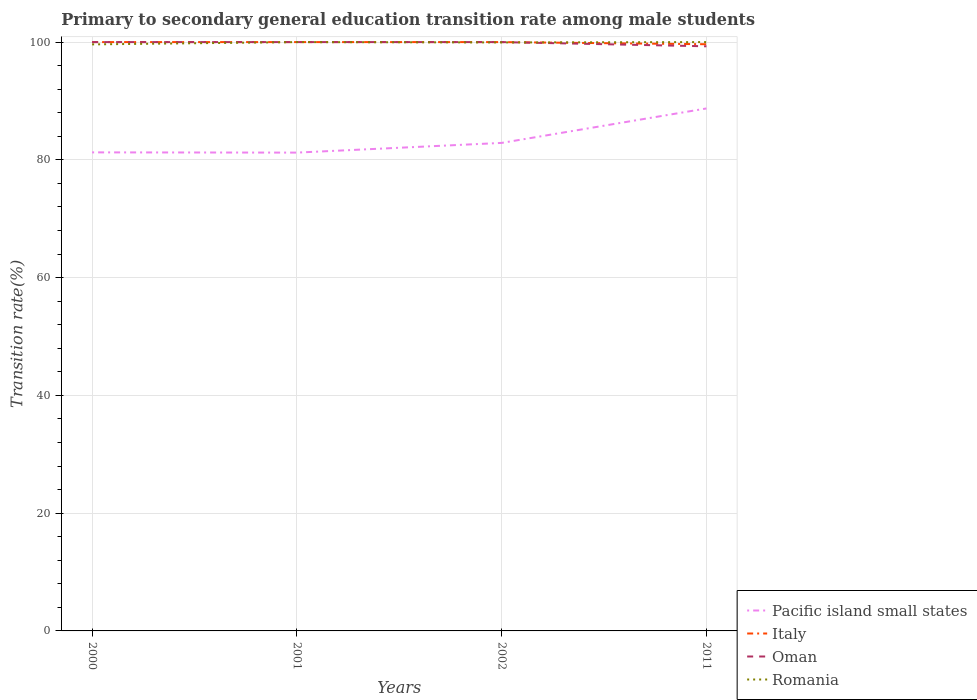Does the line corresponding to Romania intersect with the line corresponding to Italy?
Ensure brevity in your answer.  Yes. Across all years, what is the maximum transition rate in Italy?
Ensure brevity in your answer.  99.64. In which year was the transition rate in Pacific island small states maximum?
Keep it short and to the point. 2001. What is the total transition rate in Pacific island small states in the graph?
Your answer should be compact. -1.61. What is the difference between the highest and the second highest transition rate in Italy?
Offer a very short reply. 0.36. What is the difference between the highest and the lowest transition rate in Romania?
Provide a short and direct response. 3. Is the transition rate in Oman strictly greater than the transition rate in Pacific island small states over the years?
Your answer should be compact. No. How many lines are there?
Your response must be concise. 4. What is the difference between two consecutive major ticks on the Y-axis?
Offer a terse response. 20. Are the values on the major ticks of Y-axis written in scientific E-notation?
Your response must be concise. No. How many legend labels are there?
Ensure brevity in your answer.  4. How are the legend labels stacked?
Provide a succinct answer. Vertical. What is the title of the graph?
Your answer should be very brief. Primary to secondary general education transition rate among male students. Does "Colombia" appear as one of the legend labels in the graph?
Your answer should be compact. No. What is the label or title of the X-axis?
Give a very brief answer. Years. What is the label or title of the Y-axis?
Give a very brief answer. Transition rate(%). What is the Transition rate(%) in Pacific island small states in 2000?
Give a very brief answer. 81.27. What is the Transition rate(%) in Italy in 2000?
Keep it short and to the point. 100. What is the Transition rate(%) in Romania in 2000?
Your answer should be compact. 99.61. What is the Transition rate(%) of Pacific island small states in 2001?
Keep it short and to the point. 81.23. What is the Transition rate(%) of Italy in 2001?
Provide a short and direct response. 100. What is the Transition rate(%) in Oman in 2001?
Ensure brevity in your answer.  100. What is the Transition rate(%) of Romania in 2001?
Provide a short and direct response. 100. What is the Transition rate(%) in Pacific island small states in 2002?
Keep it short and to the point. 82.88. What is the Transition rate(%) of Romania in 2002?
Ensure brevity in your answer.  99.94. What is the Transition rate(%) in Pacific island small states in 2011?
Ensure brevity in your answer.  88.73. What is the Transition rate(%) of Italy in 2011?
Your answer should be very brief. 99.64. What is the Transition rate(%) of Oman in 2011?
Keep it short and to the point. 99.29. What is the Transition rate(%) of Romania in 2011?
Give a very brief answer. 100. Across all years, what is the maximum Transition rate(%) of Pacific island small states?
Your answer should be very brief. 88.73. Across all years, what is the maximum Transition rate(%) in Italy?
Ensure brevity in your answer.  100. Across all years, what is the maximum Transition rate(%) in Romania?
Your answer should be compact. 100. Across all years, what is the minimum Transition rate(%) in Pacific island small states?
Keep it short and to the point. 81.23. Across all years, what is the minimum Transition rate(%) in Italy?
Your response must be concise. 99.64. Across all years, what is the minimum Transition rate(%) of Oman?
Your answer should be very brief. 99.29. Across all years, what is the minimum Transition rate(%) of Romania?
Make the answer very short. 99.61. What is the total Transition rate(%) in Pacific island small states in the graph?
Keep it short and to the point. 334.12. What is the total Transition rate(%) in Italy in the graph?
Offer a very short reply. 399.64. What is the total Transition rate(%) in Oman in the graph?
Ensure brevity in your answer.  399.29. What is the total Transition rate(%) of Romania in the graph?
Give a very brief answer. 399.55. What is the difference between the Transition rate(%) in Pacific island small states in 2000 and that in 2001?
Ensure brevity in your answer.  0.04. What is the difference between the Transition rate(%) in Italy in 2000 and that in 2001?
Give a very brief answer. 0. What is the difference between the Transition rate(%) of Romania in 2000 and that in 2001?
Your response must be concise. -0.39. What is the difference between the Transition rate(%) in Pacific island small states in 2000 and that in 2002?
Ensure brevity in your answer.  -1.61. What is the difference between the Transition rate(%) of Romania in 2000 and that in 2002?
Provide a short and direct response. -0.33. What is the difference between the Transition rate(%) in Pacific island small states in 2000 and that in 2011?
Keep it short and to the point. -7.46. What is the difference between the Transition rate(%) of Italy in 2000 and that in 2011?
Provide a succinct answer. 0.36. What is the difference between the Transition rate(%) in Oman in 2000 and that in 2011?
Offer a terse response. 0.71. What is the difference between the Transition rate(%) of Romania in 2000 and that in 2011?
Offer a very short reply. -0.39. What is the difference between the Transition rate(%) in Pacific island small states in 2001 and that in 2002?
Keep it short and to the point. -1.65. What is the difference between the Transition rate(%) of Romania in 2001 and that in 2002?
Provide a short and direct response. 0.06. What is the difference between the Transition rate(%) in Pacific island small states in 2001 and that in 2011?
Your answer should be very brief. -7.5. What is the difference between the Transition rate(%) of Italy in 2001 and that in 2011?
Provide a succinct answer. 0.36. What is the difference between the Transition rate(%) of Oman in 2001 and that in 2011?
Make the answer very short. 0.71. What is the difference between the Transition rate(%) in Pacific island small states in 2002 and that in 2011?
Make the answer very short. -5.85. What is the difference between the Transition rate(%) in Italy in 2002 and that in 2011?
Offer a very short reply. 0.36. What is the difference between the Transition rate(%) of Oman in 2002 and that in 2011?
Provide a short and direct response. 0.71. What is the difference between the Transition rate(%) in Romania in 2002 and that in 2011?
Offer a very short reply. -0.06. What is the difference between the Transition rate(%) in Pacific island small states in 2000 and the Transition rate(%) in Italy in 2001?
Your answer should be compact. -18.73. What is the difference between the Transition rate(%) of Pacific island small states in 2000 and the Transition rate(%) of Oman in 2001?
Your answer should be compact. -18.73. What is the difference between the Transition rate(%) in Pacific island small states in 2000 and the Transition rate(%) in Romania in 2001?
Your response must be concise. -18.73. What is the difference between the Transition rate(%) of Pacific island small states in 2000 and the Transition rate(%) of Italy in 2002?
Keep it short and to the point. -18.73. What is the difference between the Transition rate(%) of Pacific island small states in 2000 and the Transition rate(%) of Oman in 2002?
Provide a short and direct response. -18.73. What is the difference between the Transition rate(%) in Pacific island small states in 2000 and the Transition rate(%) in Romania in 2002?
Your answer should be compact. -18.67. What is the difference between the Transition rate(%) in Italy in 2000 and the Transition rate(%) in Romania in 2002?
Provide a short and direct response. 0.06. What is the difference between the Transition rate(%) of Oman in 2000 and the Transition rate(%) of Romania in 2002?
Provide a succinct answer. 0.06. What is the difference between the Transition rate(%) in Pacific island small states in 2000 and the Transition rate(%) in Italy in 2011?
Ensure brevity in your answer.  -18.36. What is the difference between the Transition rate(%) in Pacific island small states in 2000 and the Transition rate(%) in Oman in 2011?
Offer a terse response. -18.01. What is the difference between the Transition rate(%) of Pacific island small states in 2000 and the Transition rate(%) of Romania in 2011?
Provide a short and direct response. -18.73. What is the difference between the Transition rate(%) in Italy in 2000 and the Transition rate(%) in Oman in 2011?
Provide a succinct answer. 0.71. What is the difference between the Transition rate(%) of Pacific island small states in 2001 and the Transition rate(%) of Italy in 2002?
Keep it short and to the point. -18.77. What is the difference between the Transition rate(%) in Pacific island small states in 2001 and the Transition rate(%) in Oman in 2002?
Ensure brevity in your answer.  -18.77. What is the difference between the Transition rate(%) in Pacific island small states in 2001 and the Transition rate(%) in Romania in 2002?
Keep it short and to the point. -18.71. What is the difference between the Transition rate(%) of Italy in 2001 and the Transition rate(%) of Oman in 2002?
Make the answer very short. 0. What is the difference between the Transition rate(%) in Italy in 2001 and the Transition rate(%) in Romania in 2002?
Provide a succinct answer. 0.06. What is the difference between the Transition rate(%) in Oman in 2001 and the Transition rate(%) in Romania in 2002?
Make the answer very short. 0.06. What is the difference between the Transition rate(%) in Pacific island small states in 2001 and the Transition rate(%) in Italy in 2011?
Your answer should be compact. -18.4. What is the difference between the Transition rate(%) of Pacific island small states in 2001 and the Transition rate(%) of Oman in 2011?
Make the answer very short. -18.05. What is the difference between the Transition rate(%) in Pacific island small states in 2001 and the Transition rate(%) in Romania in 2011?
Give a very brief answer. -18.77. What is the difference between the Transition rate(%) of Italy in 2001 and the Transition rate(%) of Oman in 2011?
Offer a terse response. 0.71. What is the difference between the Transition rate(%) of Oman in 2001 and the Transition rate(%) of Romania in 2011?
Your answer should be compact. 0. What is the difference between the Transition rate(%) in Pacific island small states in 2002 and the Transition rate(%) in Italy in 2011?
Make the answer very short. -16.76. What is the difference between the Transition rate(%) in Pacific island small states in 2002 and the Transition rate(%) in Oman in 2011?
Provide a succinct answer. -16.41. What is the difference between the Transition rate(%) of Pacific island small states in 2002 and the Transition rate(%) of Romania in 2011?
Make the answer very short. -17.12. What is the difference between the Transition rate(%) of Italy in 2002 and the Transition rate(%) of Oman in 2011?
Your answer should be compact. 0.71. What is the average Transition rate(%) in Pacific island small states per year?
Give a very brief answer. 83.53. What is the average Transition rate(%) of Italy per year?
Provide a succinct answer. 99.91. What is the average Transition rate(%) of Oman per year?
Provide a succinct answer. 99.82. What is the average Transition rate(%) of Romania per year?
Offer a very short reply. 99.89. In the year 2000, what is the difference between the Transition rate(%) of Pacific island small states and Transition rate(%) of Italy?
Give a very brief answer. -18.73. In the year 2000, what is the difference between the Transition rate(%) in Pacific island small states and Transition rate(%) in Oman?
Your answer should be very brief. -18.73. In the year 2000, what is the difference between the Transition rate(%) in Pacific island small states and Transition rate(%) in Romania?
Offer a very short reply. -18.34. In the year 2000, what is the difference between the Transition rate(%) in Italy and Transition rate(%) in Romania?
Keep it short and to the point. 0.39. In the year 2000, what is the difference between the Transition rate(%) in Oman and Transition rate(%) in Romania?
Offer a very short reply. 0.39. In the year 2001, what is the difference between the Transition rate(%) of Pacific island small states and Transition rate(%) of Italy?
Your answer should be very brief. -18.77. In the year 2001, what is the difference between the Transition rate(%) in Pacific island small states and Transition rate(%) in Oman?
Your answer should be very brief. -18.77. In the year 2001, what is the difference between the Transition rate(%) of Pacific island small states and Transition rate(%) of Romania?
Give a very brief answer. -18.77. In the year 2001, what is the difference between the Transition rate(%) of Italy and Transition rate(%) of Romania?
Keep it short and to the point. 0. In the year 2002, what is the difference between the Transition rate(%) in Pacific island small states and Transition rate(%) in Italy?
Provide a short and direct response. -17.12. In the year 2002, what is the difference between the Transition rate(%) of Pacific island small states and Transition rate(%) of Oman?
Give a very brief answer. -17.12. In the year 2002, what is the difference between the Transition rate(%) of Pacific island small states and Transition rate(%) of Romania?
Your answer should be very brief. -17.06. In the year 2002, what is the difference between the Transition rate(%) of Italy and Transition rate(%) of Oman?
Ensure brevity in your answer.  0. In the year 2002, what is the difference between the Transition rate(%) in Italy and Transition rate(%) in Romania?
Your answer should be compact. 0.06. In the year 2002, what is the difference between the Transition rate(%) of Oman and Transition rate(%) of Romania?
Your response must be concise. 0.06. In the year 2011, what is the difference between the Transition rate(%) in Pacific island small states and Transition rate(%) in Italy?
Your answer should be very brief. -10.91. In the year 2011, what is the difference between the Transition rate(%) in Pacific island small states and Transition rate(%) in Oman?
Your answer should be very brief. -10.56. In the year 2011, what is the difference between the Transition rate(%) in Pacific island small states and Transition rate(%) in Romania?
Give a very brief answer. -11.27. In the year 2011, what is the difference between the Transition rate(%) in Italy and Transition rate(%) in Oman?
Offer a very short reply. 0.35. In the year 2011, what is the difference between the Transition rate(%) of Italy and Transition rate(%) of Romania?
Your answer should be very brief. -0.36. In the year 2011, what is the difference between the Transition rate(%) in Oman and Transition rate(%) in Romania?
Offer a very short reply. -0.71. What is the ratio of the Transition rate(%) of Italy in 2000 to that in 2001?
Make the answer very short. 1. What is the ratio of the Transition rate(%) in Romania in 2000 to that in 2001?
Make the answer very short. 1. What is the ratio of the Transition rate(%) in Pacific island small states in 2000 to that in 2002?
Offer a very short reply. 0.98. What is the ratio of the Transition rate(%) of Italy in 2000 to that in 2002?
Make the answer very short. 1. What is the ratio of the Transition rate(%) of Oman in 2000 to that in 2002?
Your response must be concise. 1. What is the ratio of the Transition rate(%) in Romania in 2000 to that in 2002?
Your answer should be very brief. 1. What is the ratio of the Transition rate(%) in Pacific island small states in 2000 to that in 2011?
Offer a terse response. 0.92. What is the ratio of the Transition rate(%) in Italy in 2000 to that in 2011?
Your response must be concise. 1. What is the ratio of the Transition rate(%) in Oman in 2000 to that in 2011?
Keep it short and to the point. 1.01. What is the ratio of the Transition rate(%) of Pacific island small states in 2001 to that in 2002?
Give a very brief answer. 0.98. What is the ratio of the Transition rate(%) in Italy in 2001 to that in 2002?
Give a very brief answer. 1. What is the ratio of the Transition rate(%) in Oman in 2001 to that in 2002?
Offer a very short reply. 1. What is the ratio of the Transition rate(%) in Pacific island small states in 2001 to that in 2011?
Ensure brevity in your answer.  0.92. What is the ratio of the Transition rate(%) in Italy in 2001 to that in 2011?
Keep it short and to the point. 1. What is the ratio of the Transition rate(%) in Romania in 2001 to that in 2011?
Keep it short and to the point. 1. What is the ratio of the Transition rate(%) of Pacific island small states in 2002 to that in 2011?
Provide a short and direct response. 0.93. What is the ratio of the Transition rate(%) of Romania in 2002 to that in 2011?
Give a very brief answer. 1. What is the difference between the highest and the second highest Transition rate(%) in Pacific island small states?
Your response must be concise. 5.85. What is the difference between the highest and the second highest Transition rate(%) in Italy?
Provide a short and direct response. 0. What is the difference between the highest and the lowest Transition rate(%) of Pacific island small states?
Your answer should be compact. 7.5. What is the difference between the highest and the lowest Transition rate(%) in Italy?
Give a very brief answer. 0.36. What is the difference between the highest and the lowest Transition rate(%) of Oman?
Your answer should be compact. 0.71. What is the difference between the highest and the lowest Transition rate(%) of Romania?
Offer a very short reply. 0.39. 